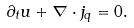Convert formula to latex. <formula><loc_0><loc_0><loc_500><loc_500>\partial _ { t } { u } + \nabla \cdot { j } _ { q } = 0 .</formula> 